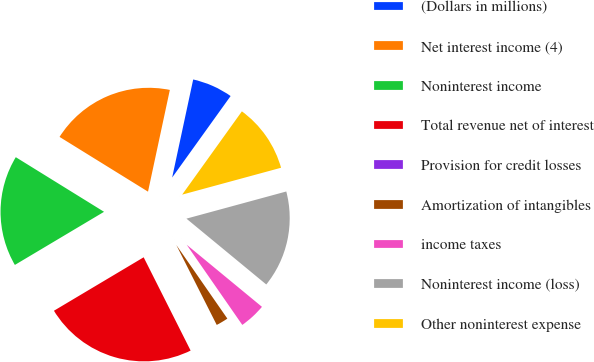Convert chart. <chart><loc_0><loc_0><loc_500><loc_500><pie_chart><fcel>(Dollars in millions)<fcel>Net interest income (4)<fcel>Noninterest income<fcel>Total revenue net of interest<fcel>Provision for credit losses<fcel>Amortization of intangibles<fcel>income taxes<fcel>Noninterest income (loss)<fcel>Other noninterest expense<nl><fcel>6.54%<fcel>19.54%<fcel>17.37%<fcel>23.87%<fcel>0.03%<fcel>2.2%<fcel>4.37%<fcel>15.2%<fcel>10.87%<nl></chart> 